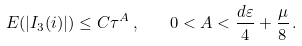Convert formula to latex. <formula><loc_0><loc_0><loc_500><loc_500>E ( | I _ { 3 } ( i ) | ) \leq C \tau ^ { A } \, , \quad 0 < A < \frac { d \varepsilon } { 4 } + \frac { \mu } { 8 } \, .</formula> 